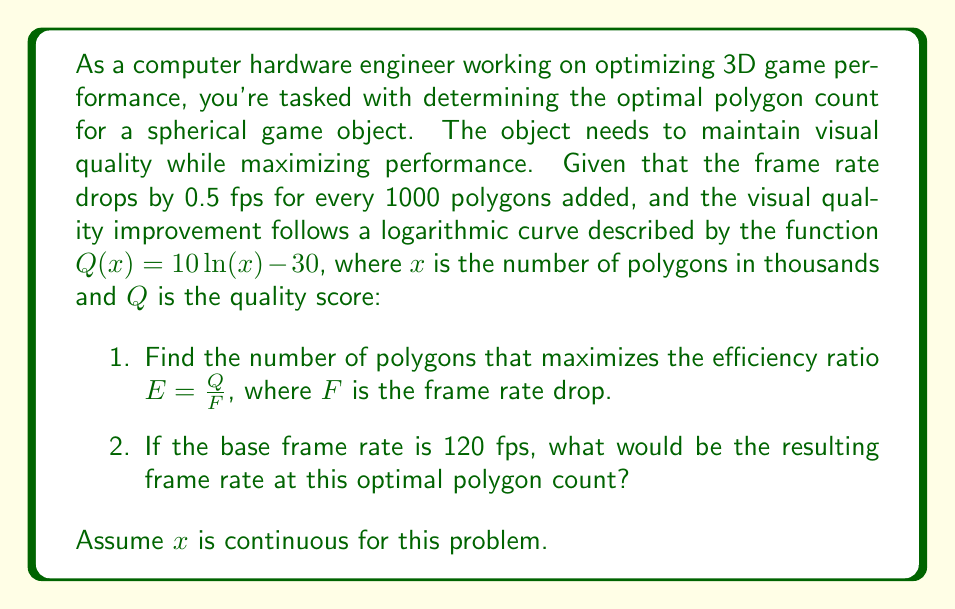Can you solve this math problem? Let's approach this step-by-step:

1) First, we need to express the efficiency ratio $E$ in terms of $x$:

   $E = \frac{Q}{F} = \frac{10 \ln(x) - 30}{0.5x}$

2) To find the maximum value of $E$, we need to find where its derivative equals zero:

   $$\frac{dE}{dx} = \frac{(10 \ln(x) - 30) \cdot (-0.5) + 0.5x \cdot \frac{10}{x}}{(0.5x)^2} = 0$$

3) Simplifying:

   $$\frac{-5 \ln(x) + 15 + 10}{0.25x^2} = 0$$

   $$-5 \ln(x) + 25 = 0$$

   $$\ln(x) = 5$$

4) Solving for $x$:

   $$x = e^5 \approx 148.4$$

5) This means the optimal number of polygons is about 148,400.

6) To find the resulting frame rate:

   Frame rate drop = $0.5 \cdot 148.4 = 74.2$ fps

   Resulting frame rate = $120 - 74.2 = 45.8$ fps
Answer: 1. The optimal polygon count is approximately 148,400 polygons.
2. The resulting frame rate would be approximately 45.8 fps. 